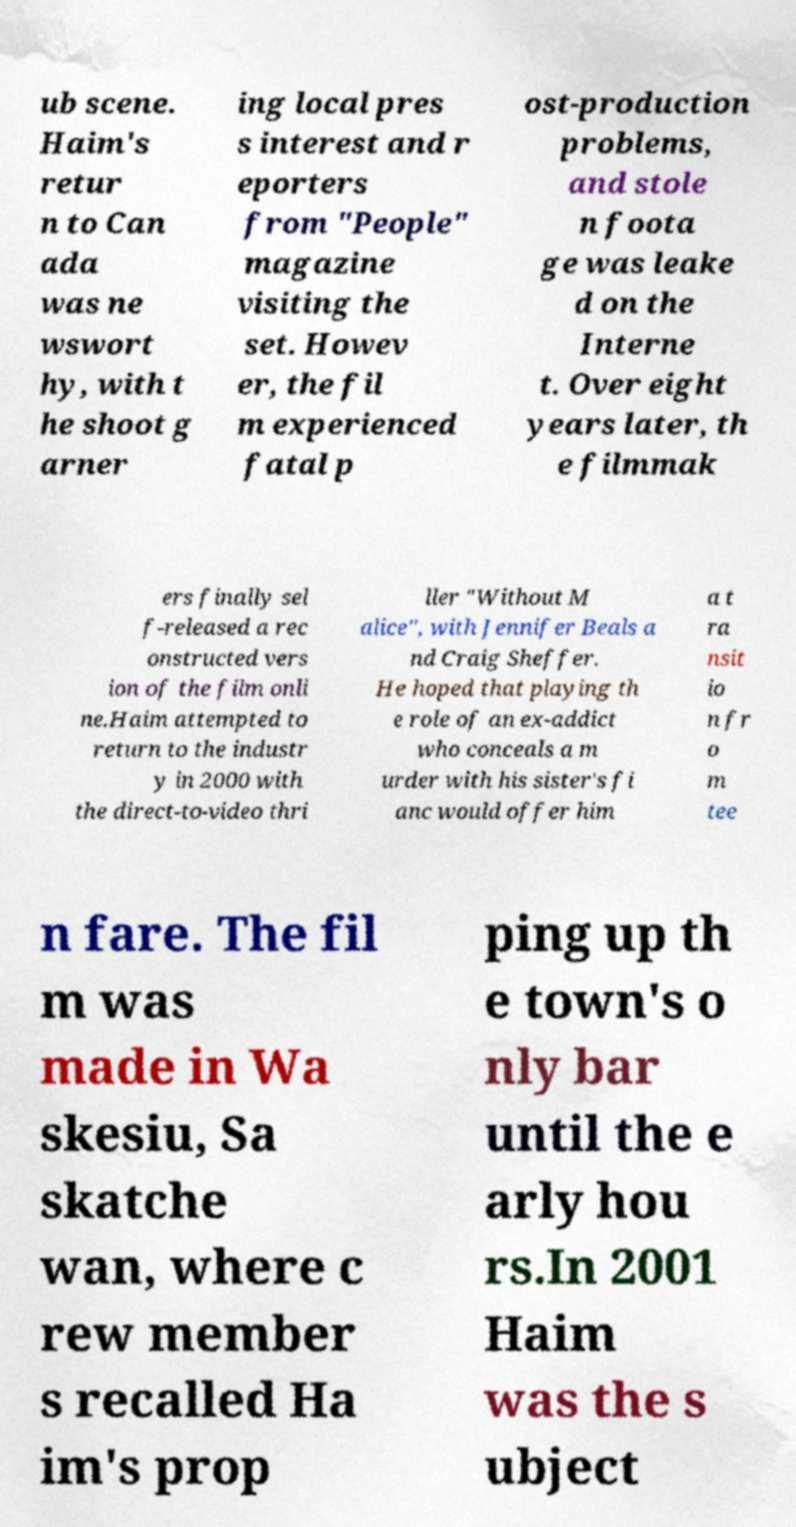Can you accurately transcribe the text from the provided image for me? ub scene. Haim's retur n to Can ada was ne wswort hy, with t he shoot g arner ing local pres s interest and r eporters from "People" magazine visiting the set. Howev er, the fil m experienced fatal p ost-production problems, and stole n foota ge was leake d on the Interne t. Over eight years later, th e filmmak ers finally sel f-released a rec onstructed vers ion of the film onli ne.Haim attempted to return to the industr y in 2000 with the direct-to-video thri ller "Without M alice", with Jennifer Beals a nd Craig Sheffer. He hoped that playing th e role of an ex-addict who conceals a m urder with his sister's fi anc would offer him a t ra nsit io n fr o m tee n fare. The fil m was made in Wa skesiu, Sa skatche wan, where c rew member s recalled Ha im's prop ping up th e town's o nly bar until the e arly hou rs.In 2001 Haim was the s ubject 